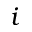<formula> <loc_0><loc_0><loc_500><loc_500>i</formula> 